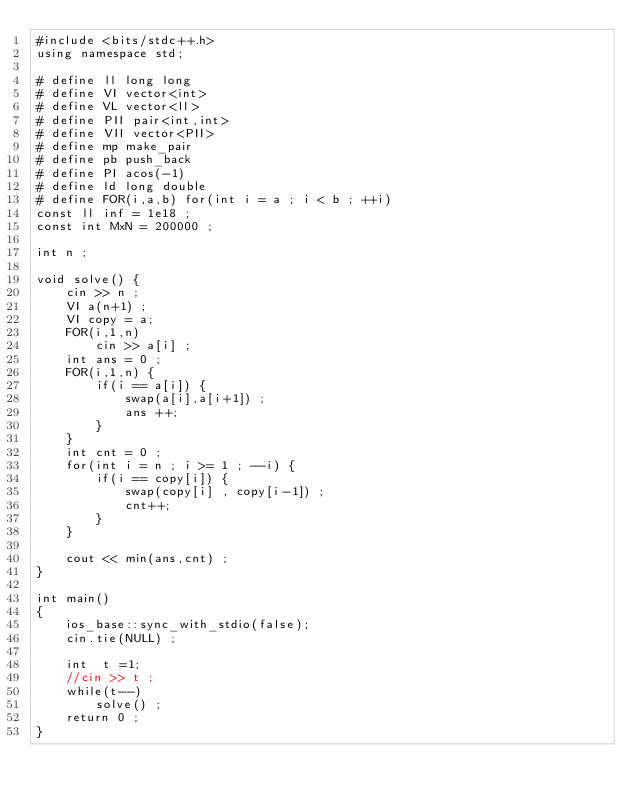<code> <loc_0><loc_0><loc_500><loc_500><_C++_>#include <bits/stdc++.h>
using namespace std;

# define ll long long 
# define VI vector<int>
# define VL vector<ll>
# define PII pair<int,int> 
# define VII vector<PII>
# define mp make_pair
# define pb push_back
# define PI acos(-1)
# define ld long double
# define FOR(i,a,b) for(int i = a ; i < b ; ++i) 
const ll inf = 1e18 ; 
const int MxN = 200000 ; 

int n ; 

void solve() {
	cin >> n ; 
	VI a(n+1) ; 
	VI copy = a; 
	FOR(i,1,n) 
		cin >> a[i] ; 
	int ans = 0 ; 
	FOR(i,1,n) {
		if(i == a[i]) {
			swap(a[i],a[i+1]) ; 
			ans ++; 
		}
	}
	int cnt = 0 ; 
	for(int i = n ; i >= 1 ; --i) {
		if(i == copy[i]) {
			swap(copy[i] , copy[i-1]) ;
			cnt++;
		}
	}

	cout << min(ans,cnt) ; 
}

int main()
{
	ios_base::sync_with_stdio(false);
	cin.tie(NULL) ; 
	
	int  t =1; 
	//cin >> t ; 
	while(t--)
		solve() ; 
	return 0 ; 
}

</code> 